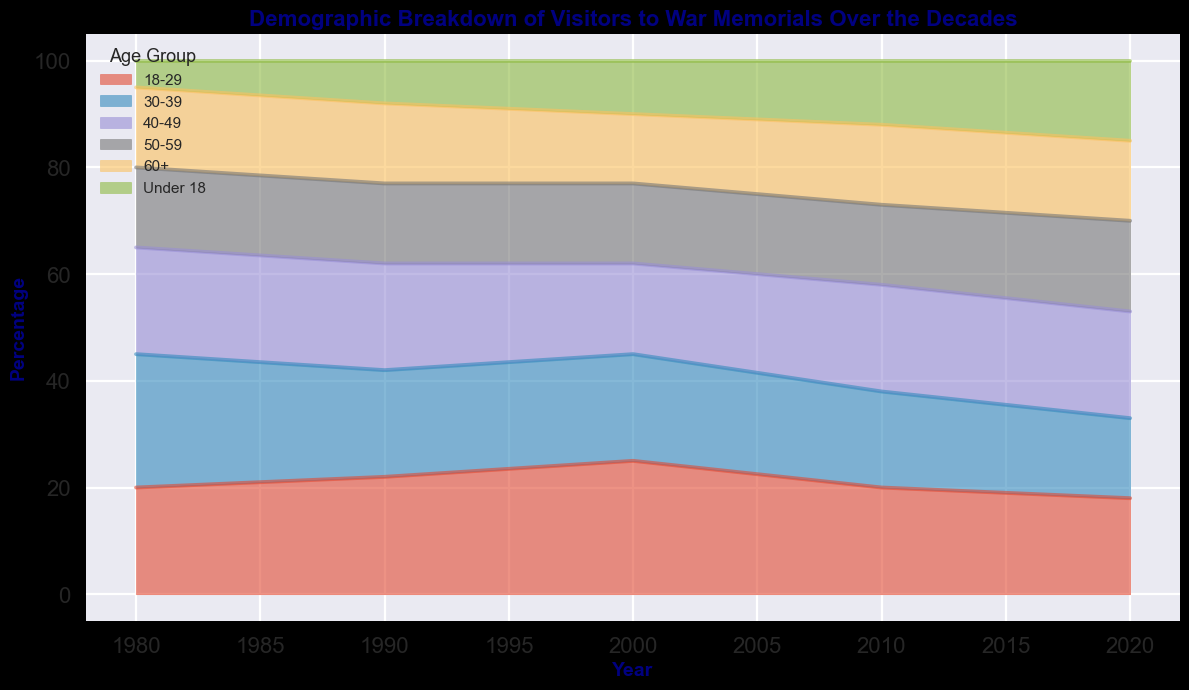what general trend can be observed in the percentage of visitors under 18 from 1980 to 2020? The general trend can be observed by looking at the heights of the areas corresponding to the "Under 18" category across the years. The percentage of visitors under 18 started at 5% in 1980, increased to 8% in 1990, 10% in 2000, 12% in 2010, and finally reached 15% in 2020.
Answer: An overall increase which age group had the highest percentage of visitors in 2000? To determine the age group with the highest percentage of visitors in 2000, look for the highest point in the 2000 vertical slice of the area plot. The "18-29" age group had the highest percentage of visitors, at 25%.
Answer: 18-29 how does the percentage of visitors aged 60+ in 2020 compare to 1980? To compare the percentages, note the heights of the "60+" areas for 2020 and 1980. Both years have the "60+" category at 15%, so the percentage stayed the same.
Answer: no change What changes occurred in the percentage of visitors aged 30-39 between 2010 and 2020? Look at the heights of the area corresponding to the "30-39" age group for 2010 and 2020. In 2010, it was 18%, while in 2020, it decreased to 15%.
Answer: decreased by 3% Which age group had the most significant increase in the percentage of visitors from 2000 to 2020? To identify the largest increase, subtract the 2000 percentage from the 2020 percentage for each age group and compare. The "Under 18" group increased from 10% in 2000 to 15% in 2020, an increase of 5%, the largest among all groups.
Answer: Under 18 What is the sum of the percentages for visitors aged 40-49 and 50-59 in 2020? Add the percentages for the "40-49" and "50-59" age groups in 2020: 20% + 17%.
Answer: 37% How did the percentage of visitors aged 18-29 change from 1990 to 2020? Look at the heights of the "18-29" area for 1990 and 2020. In 1990, it was 22%, while in 2020, it was 18%.
Answer: decreased by 4% Which age group had a relatively constant percentage of visitors across all decades? Inspect the area plot for groups that maintain a roughly constant height across all time slices. The "50-59" age group is consistently around 15% across all decades.
Answer: 50-59 Is the average percentage of visitors aged 50-59 greater than that of visitors aged under 18 from 1980 to 2020? Calculate the average percentage over the years for both age groups. The average for "50-59" is (15+15+15+15+17)/5 = 15.4%, and for "Under 18" is (5+8+10+12+15)/5 = 10%.
Answer: Yes In which decade did the "30-39" age group experience the most significant decrease in the percentage of visitors compared to the previous decade? Calculate the percentage decrease between decades. The most significant decrease between the closest decades is from 1990 to 2000, going from 20% to 20%,  to 18%, which is a 3% change for the age group "30-39".
Answer: 1990 to 2000 